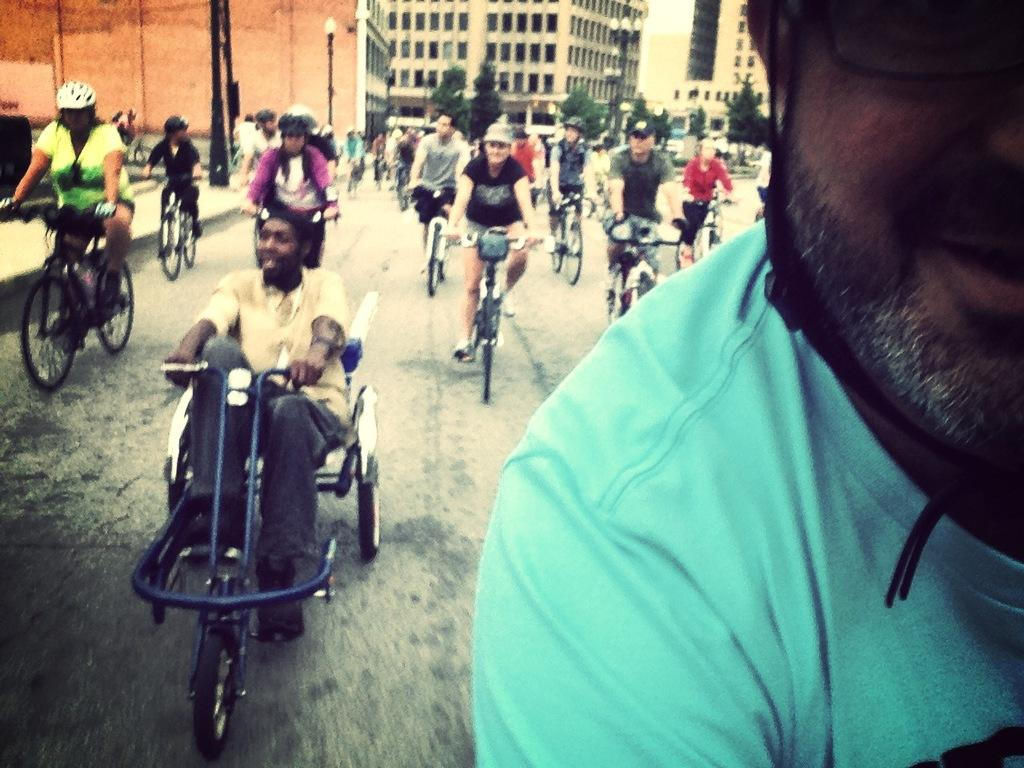How many people are in the image? There is a group of people in the image. What are the people doing in the image? The people are riding bicycles. Where are the bicycle riders located? The bicycle riders are on the road. What safety precaution are the bicycle riders taking? The bicycle riders are wearing helmets. What can be seen in the background of the image? There is a building, a pole, a light, and trees in the background of the image. What type of silk fabric is draped over the knife in the image? There is no knife or silk fabric present in the image. 